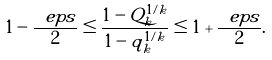Convert formula to latex. <formula><loc_0><loc_0><loc_500><loc_500>1 - \frac { \ e p s } { 2 } \leq \frac { 1 - Q _ { k } ^ { 1 / k } } { 1 - q _ { k } ^ { 1 / k } } \leq 1 + \frac { \ e p s } { 2 } .</formula> 